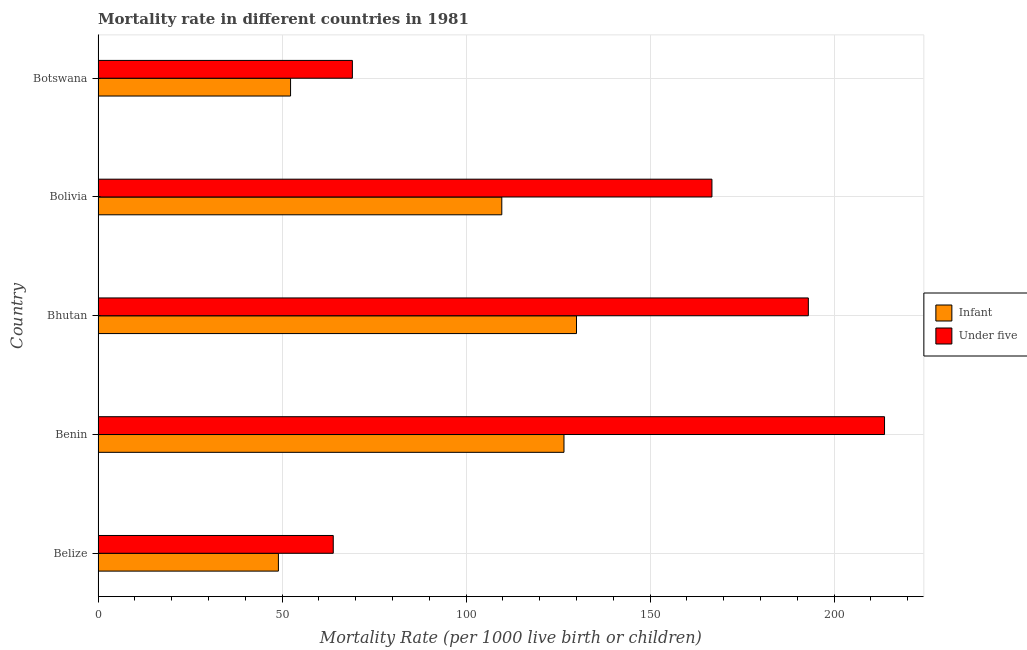How many bars are there on the 5th tick from the top?
Your response must be concise. 2. How many bars are there on the 4th tick from the bottom?
Keep it short and to the point. 2. What is the label of the 3rd group of bars from the top?
Your response must be concise. Bhutan. In how many cases, is the number of bars for a given country not equal to the number of legend labels?
Make the answer very short. 0. What is the under-5 mortality rate in Belize?
Keep it short and to the point. 63.9. Across all countries, what is the maximum under-5 mortality rate?
Your answer should be very brief. 213.7. Across all countries, what is the minimum under-5 mortality rate?
Give a very brief answer. 63.9. In which country was the under-5 mortality rate maximum?
Offer a terse response. Benin. In which country was the under-5 mortality rate minimum?
Provide a succinct answer. Belize. What is the total infant mortality rate in the graph?
Offer a terse response. 467.6. What is the difference between the infant mortality rate in Benin and that in Bhutan?
Provide a short and direct response. -3.4. What is the difference between the under-5 mortality rate in Botswana and the infant mortality rate in Bhutan?
Make the answer very short. -60.9. What is the average infant mortality rate per country?
Offer a very short reply. 93.52. What is the ratio of the infant mortality rate in Bolivia to that in Botswana?
Your answer should be compact. 2.1. Is the infant mortality rate in Benin less than that in Botswana?
Make the answer very short. No. Is the difference between the under-5 mortality rate in Belize and Bhutan greater than the difference between the infant mortality rate in Belize and Bhutan?
Your response must be concise. No. In how many countries, is the infant mortality rate greater than the average infant mortality rate taken over all countries?
Offer a very short reply. 3. What does the 2nd bar from the top in Belize represents?
Your answer should be compact. Infant. What does the 2nd bar from the bottom in Belize represents?
Make the answer very short. Under five. How many bars are there?
Your answer should be compact. 10. What is the difference between two consecutive major ticks on the X-axis?
Your answer should be very brief. 50. Are the values on the major ticks of X-axis written in scientific E-notation?
Your answer should be compact. No. How many legend labels are there?
Provide a succinct answer. 2. How are the legend labels stacked?
Your answer should be compact. Vertical. What is the title of the graph?
Give a very brief answer. Mortality rate in different countries in 1981. What is the label or title of the X-axis?
Give a very brief answer. Mortality Rate (per 1000 live birth or children). What is the Mortality Rate (per 1000 live birth or children) in Infant in Belize?
Give a very brief answer. 49. What is the Mortality Rate (per 1000 live birth or children) in Under five in Belize?
Your response must be concise. 63.9. What is the Mortality Rate (per 1000 live birth or children) of Infant in Benin?
Offer a very short reply. 126.6. What is the Mortality Rate (per 1000 live birth or children) in Under five in Benin?
Your response must be concise. 213.7. What is the Mortality Rate (per 1000 live birth or children) of Infant in Bhutan?
Give a very brief answer. 130. What is the Mortality Rate (per 1000 live birth or children) in Under five in Bhutan?
Offer a terse response. 193. What is the Mortality Rate (per 1000 live birth or children) in Infant in Bolivia?
Offer a very short reply. 109.7. What is the Mortality Rate (per 1000 live birth or children) of Under five in Bolivia?
Your answer should be very brief. 166.8. What is the Mortality Rate (per 1000 live birth or children) of Infant in Botswana?
Provide a succinct answer. 52.3. What is the Mortality Rate (per 1000 live birth or children) of Under five in Botswana?
Provide a succinct answer. 69.1. Across all countries, what is the maximum Mortality Rate (per 1000 live birth or children) in Infant?
Offer a very short reply. 130. Across all countries, what is the maximum Mortality Rate (per 1000 live birth or children) of Under five?
Your answer should be compact. 213.7. Across all countries, what is the minimum Mortality Rate (per 1000 live birth or children) of Infant?
Your response must be concise. 49. Across all countries, what is the minimum Mortality Rate (per 1000 live birth or children) of Under five?
Provide a succinct answer. 63.9. What is the total Mortality Rate (per 1000 live birth or children) of Infant in the graph?
Ensure brevity in your answer.  467.6. What is the total Mortality Rate (per 1000 live birth or children) in Under five in the graph?
Make the answer very short. 706.5. What is the difference between the Mortality Rate (per 1000 live birth or children) in Infant in Belize and that in Benin?
Offer a very short reply. -77.6. What is the difference between the Mortality Rate (per 1000 live birth or children) of Under five in Belize and that in Benin?
Give a very brief answer. -149.8. What is the difference between the Mortality Rate (per 1000 live birth or children) of Infant in Belize and that in Bhutan?
Make the answer very short. -81. What is the difference between the Mortality Rate (per 1000 live birth or children) in Under five in Belize and that in Bhutan?
Offer a terse response. -129.1. What is the difference between the Mortality Rate (per 1000 live birth or children) in Infant in Belize and that in Bolivia?
Your answer should be compact. -60.7. What is the difference between the Mortality Rate (per 1000 live birth or children) of Under five in Belize and that in Bolivia?
Provide a short and direct response. -102.9. What is the difference between the Mortality Rate (per 1000 live birth or children) in Infant in Belize and that in Botswana?
Provide a succinct answer. -3.3. What is the difference between the Mortality Rate (per 1000 live birth or children) in Under five in Benin and that in Bhutan?
Offer a very short reply. 20.7. What is the difference between the Mortality Rate (per 1000 live birth or children) in Infant in Benin and that in Bolivia?
Offer a terse response. 16.9. What is the difference between the Mortality Rate (per 1000 live birth or children) of Under five in Benin and that in Bolivia?
Your answer should be compact. 46.9. What is the difference between the Mortality Rate (per 1000 live birth or children) in Infant in Benin and that in Botswana?
Ensure brevity in your answer.  74.3. What is the difference between the Mortality Rate (per 1000 live birth or children) of Under five in Benin and that in Botswana?
Provide a succinct answer. 144.6. What is the difference between the Mortality Rate (per 1000 live birth or children) of Infant in Bhutan and that in Bolivia?
Keep it short and to the point. 20.3. What is the difference between the Mortality Rate (per 1000 live birth or children) of Under five in Bhutan and that in Bolivia?
Keep it short and to the point. 26.2. What is the difference between the Mortality Rate (per 1000 live birth or children) of Infant in Bhutan and that in Botswana?
Ensure brevity in your answer.  77.7. What is the difference between the Mortality Rate (per 1000 live birth or children) in Under five in Bhutan and that in Botswana?
Provide a short and direct response. 123.9. What is the difference between the Mortality Rate (per 1000 live birth or children) in Infant in Bolivia and that in Botswana?
Give a very brief answer. 57.4. What is the difference between the Mortality Rate (per 1000 live birth or children) in Under five in Bolivia and that in Botswana?
Offer a terse response. 97.7. What is the difference between the Mortality Rate (per 1000 live birth or children) of Infant in Belize and the Mortality Rate (per 1000 live birth or children) of Under five in Benin?
Offer a very short reply. -164.7. What is the difference between the Mortality Rate (per 1000 live birth or children) of Infant in Belize and the Mortality Rate (per 1000 live birth or children) of Under five in Bhutan?
Ensure brevity in your answer.  -144. What is the difference between the Mortality Rate (per 1000 live birth or children) of Infant in Belize and the Mortality Rate (per 1000 live birth or children) of Under five in Bolivia?
Your response must be concise. -117.8. What is the difference between the Mortality Rate (per 1000 live birth or children) of Infant in Belize and the Mortality Rate (per 1000 live birth or children) of Under five in Botswana?
Make the answer very short. -20.1. What is the difference between the Mortality Rate (per 1000 live birth or children) in Infant in Benin and the Mortality Rate (per 1000 live birth or children) in Under five in Bhutan?
Your answer should be compact. -66.4. What is the difference between the Mortality Rate (per 1000 live birth or children) in Infant in Benin and the Mortality Rate (per 1000 live birth or children) in Under five in Bolivia?
Your answer should be compact. -40.2. What is the difference between the Mortality Rate (per 1000 live birth or children) of Infant in Benin and the Mortality Rate (per 1000 live birth or children) of Under five in Botswana?
Your answer should be compact. 57.5. What is the difference between the Mortality Rate (per 1000 live birth or children) in Infant in Bhutan and the Mortality Rate (per 1000 live birth or children) in Under five in Bolivia?
Your answer should be compact. -36.8. What is the difference between the Mortality Rate (per 1000 live birth or children) in Infant in Bhutan and the Mortality Rate (per 1000 live birth or children) in Under five in Botswana?
Give a very brief answer. 60.9. What is the difference between the Mortality Rate (per 1000 live birth or children) of Infant in Bolivia and the Mortality Rate (per 1000 live birth or children) of Under five in Botswana?
Provide a succinct answer. 40.6. What is the average Mortality Rate (per 1000 live birth or children) of Infant per country?
Your response must be concise. 93.52. What is the average Mortality Rate (per 1000 live birth or children) of Under five per country?
Ensure brevity in your answer.  141.3. What is the difference between the Mortality Rate (per 1000 live birth or children) of Infant and Mortality Rate (per 1000 live birth or children) of Under five in Belize?
Provide a short and direct response. -14.9. What is the difference between the Mortality Rate (per 1000 live birth or children) in Infant and Mortality Rate (per 1000 live birth or children) in Under five in Benin?
Your response must be concise. -87.1. What is the difference between the Mortality Rate (per 1000 live birth or children) of Infant and Mortality Rate (per 1000 live birth or children) of Under five in Bhutan?
Ensure brevity in your answer.  -63. What is the difference between the Mortality Rate (per 1000 live birth or children) of Infant and Mortality Rate (per 1000 live birth or children) of Under five in Bolivia?
Provide a short and direct response. -57.1. What is the difference between the Mortality Rate (per 1000 live birth or children) of Infant and Mortality Rate (per 1000 live birth or children) of Under five in Botswana?
Provide a short and direct response. -16.8. What is the ratio of the Mortality Rate (per 1000 live birth or children) of Infant in Belize to that in Benin?
Provide a succinct answer. 0.39. What is the ratio of the Mortality Rate (per 1000 live birth or children) of Under five in Belize to that in Benin?
Provide a succinct answer. 0.3. What is the ratio of the Mortality Rate (per 1000 live birth or children) of Infant in Belize to that in Bhutan?
Provide a succinct answer. 0.38. What is the ratio of the Mortality Rate (per 1000 live birth or children) in Under five in Belize to that in Bhutan?
Make the answer very short. 0.33. What is the ratio of the Mortality Rate (per 1000 live birth or children) of Infant in Belize to that in Bolivia?
Offer a terse response. 0.45. What is the ratio of the Mortality Rate (per 1000 live birth or children) in Under five in Belize to that in Bolivia?
Ensure brevity in your answer.  0.38. What is the ratio of the Mortality Rate (per 1000 live birth or children) in Infant in Belize to that in Botswana?
Your response must be concise. 0.94. What is the ratio of the Mortality Rate (per 1000 live birth or children) of Under five in Belize to that in Botswana?
Provide a succinct answer. 0.92. What is the ratio of the Mortality Rate (per 1000 live birth or children) of Infant in Benin to that in Bhutan?
Give a very brief answer. 0.97. What is the ratio of the Mortality Rate (per 1000 live birth or children) in Under five in Benin to that in Bhutan?
Provide a short and direct response. 1.11. What is the ratio of the Mortality Rate (per 1000 live birth or children) in Infant in Benin to that in Bolivia?
Make the answer very short. 1.15. What is the ratio of the Mortality Rate (per 1000 live birth or children) in Under five in Benin to that in Bolivia?
Give a very brief answer. 1.28. What is the ratio of the Mortality Rate (per 1000 live birth or children) of Infant in Benin to that in Botswana?
Your response must be concise. 2.42. What is the ratio of the Mortality Rate (per 1000 live birth or children) in Under five in Benin to that in Botswana?
Give a very brief answer. 3.09. What is the ratio of the Mortality Rate (per 1000 live birth or children) of Infant in Bhutan to that in Bolivia?
Your response must be concise. 1.19. What is the ratio of the Mortality Rate (per 1000 live birth or children) in Under five in Bhutan to that in Bolivia?
Make the answer very short. 1.16. What is the ratio of the Mortality Rate (per 1000 live birth or children) in Infant in Bhutan to that in Botswana?
Offer a terse response. 2.49. What is the ratio of the Mortality Rate (per 1000 live birth or children) of Under five in Bhutan to that in Botswana?
Keep it short and to the point. 2.79. What is the ratio of the Mortality Rate (per 1000 live birth or children) in Infant in Bolivia to that in Botswana?
Make the answer very short. 2.1. What is the ratio of the Mortality Rate (per 1000 live birth or children) in Under five in Bolivia to that in Botswana?
Give a very brief answer. 2.41. What is the difference between the highest and the second highest Mortality Rate (per 1000 live birth or children) of Under five?
Give a very brief answer. 20.7. What is the difference between the highest and the lowest Mortality Rate (per 1000 live birth or children) of Infant?
Your answer should be compact. 81. What is the difference between the highest and the lowest Mortality Rate (per 1000 live birth or children) in Under five?
Offer a very short reply. 149.8. 